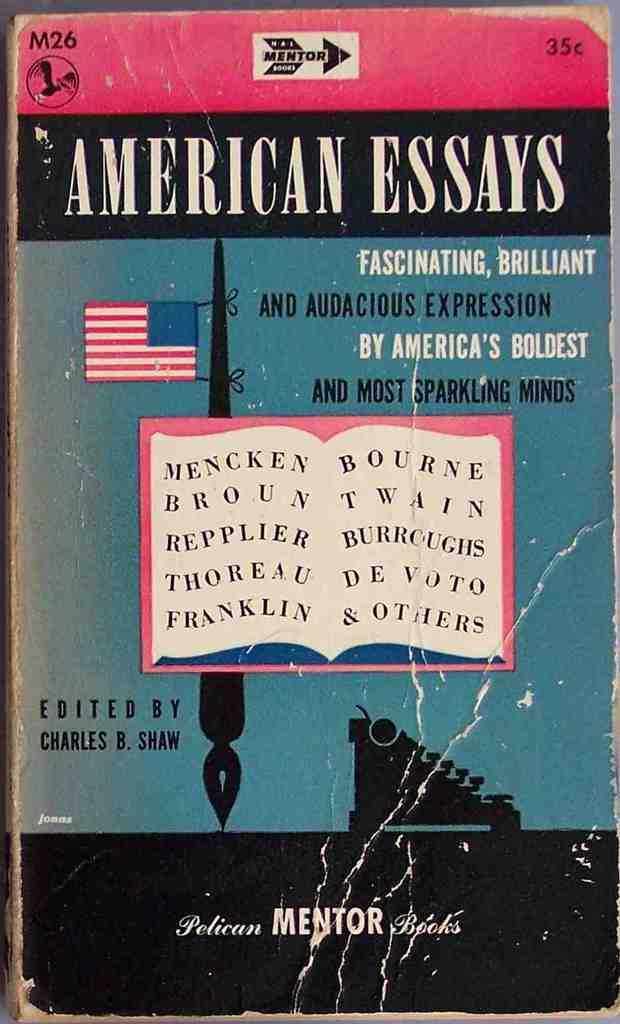What is the main subject in the center of the image? There is a poster in the center of the image. What is written on the poster? The poster has the text "American Essays" on it. How does the feeling of the chicken affect the scale of the poster in the image? There is no chicken present in the image, and therefore no such feeling can be observed. 